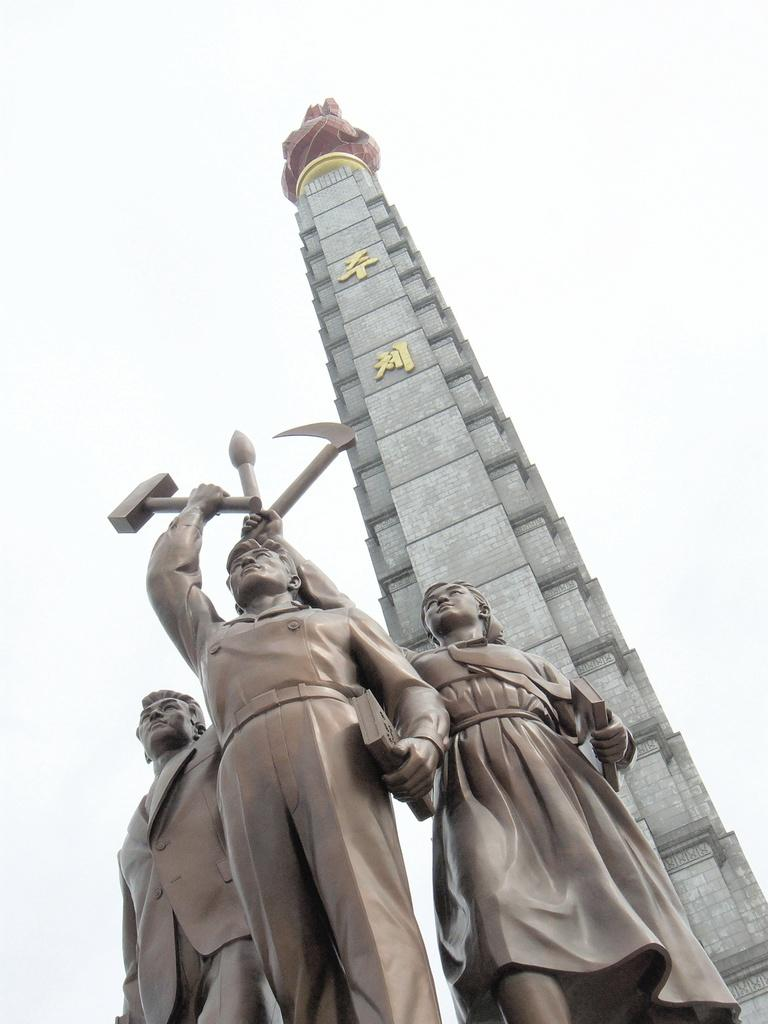What is the main subject of the image? The main subject of the image is a sculpture of three people. What are the three people in the sculpture doing? The three people are standing together and holding hammers in the sculpture. What can be seen in the background of the image? There is a tower visible in the background of the image. What type of voyage is depicted in the sculpture? The sculpture does not depict a voyage; it is a static representation of three people holding hammers. How does the sculpture affect the surrounding environment? The sculpture is an inanimate object and does not have any direct effect on the surrounding environment. 